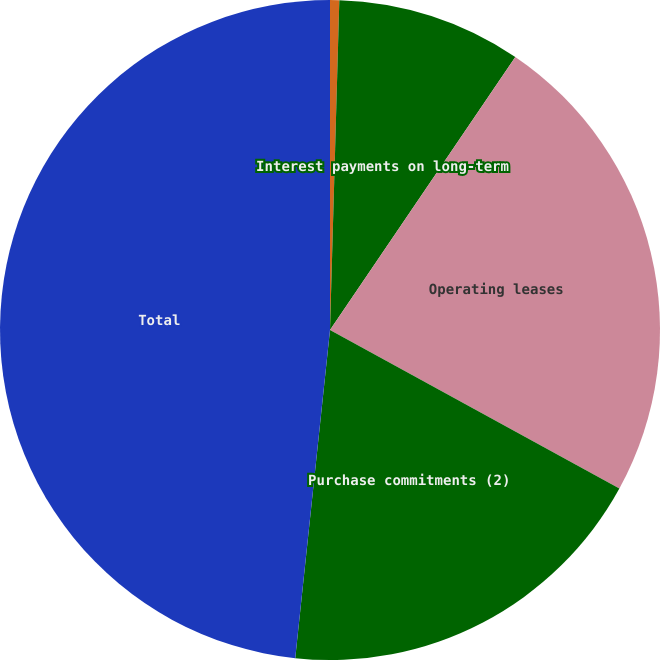Convert chart to OTSL. <chart><loc_0><loc_0><loc_500><loc_500><pie_chart><fcel>Long-term debt including<fcel>Interest payments on long-term<fcel>Operating leases<fcel>Purchase commitments (2)<fcel>Total<nl><fcel>0.45%<fcel>9.04%<fcel>23.49%<fcel>18.7%<fcel>48.32%<nl></chart> 